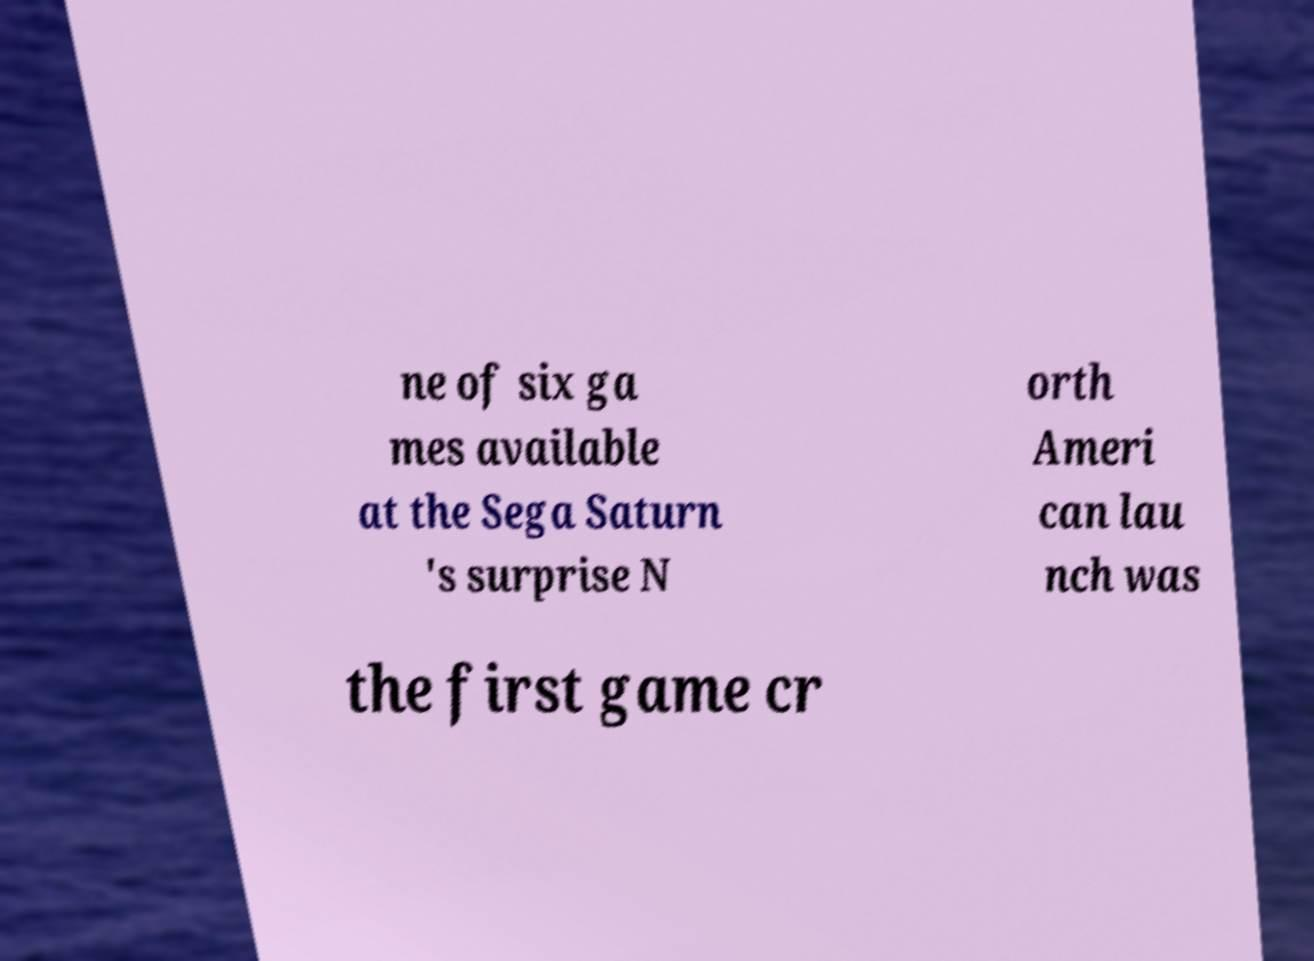Can you read and provide the text displayed in the image?This photo seems to have some interesting text. Can you extract and type it out for me? ne of six ga mes available at the Sega Saturn 's surprise N orth Ameri can lau nch was the first game cr 